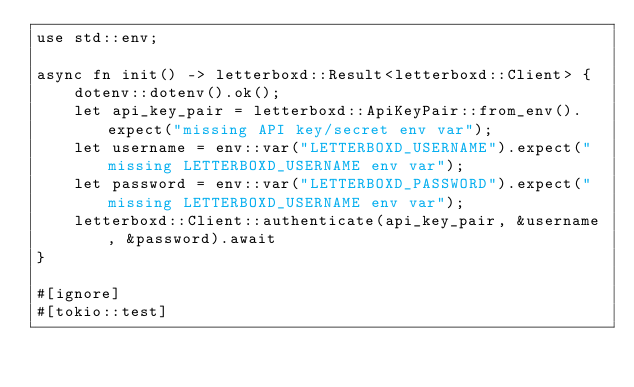Convert code to text. <code><loc_0><loc_0><loc_500><loc_500><_Rust_>use std::env;

async fn init() -> letterboxd::Result<letterboxd::Client> {
    dotenv::dotenv().ok();
    let api_key_pair = letterboxd::ApiKeyPair::from_env().expect("missing API key/secret env var");
    let username = env::var("LETTERBOXD_USERNAME").expect("missing LETTERBOXD_USERNAME env var");
    let password = env::var("LETTERBOXD_PASSWORD").expect("missing LETTERBOXD_USERNAME env var");
    letterboxd::Client::authenticate(api_key_pair, &username, &password).await
}

#[ignore]
#[tokio::test]</code> 